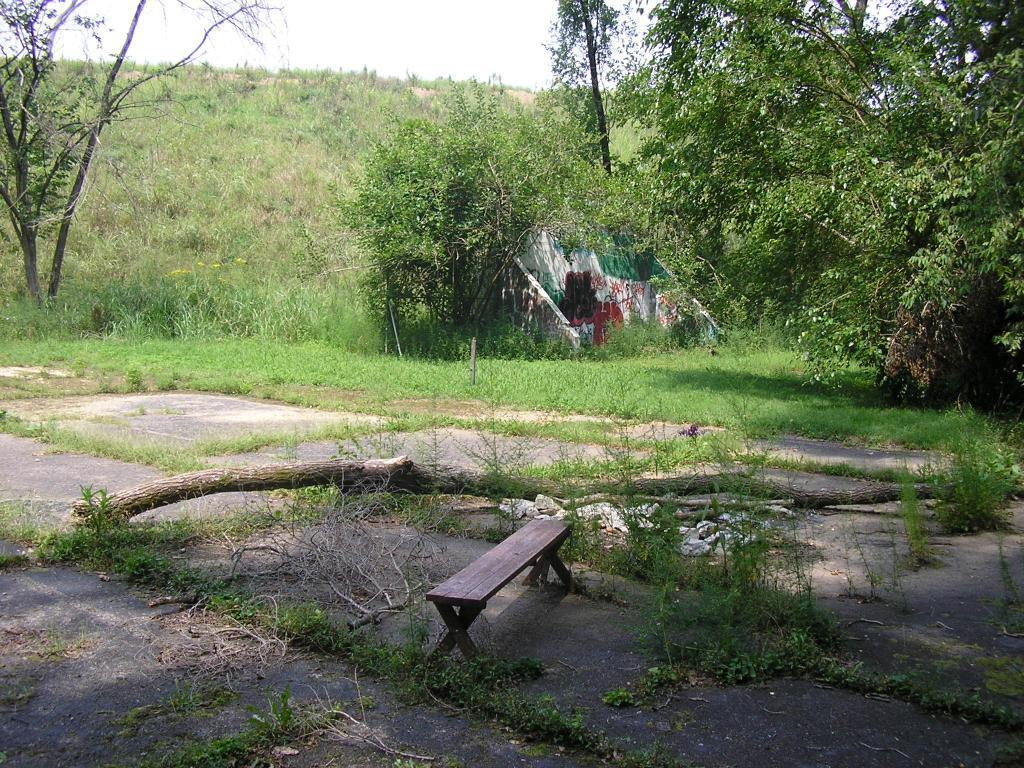What is located at the center of the image? There is a bench at the center of the image. What can be seen in the background of the image? There are trees in the background of the image. Can you see a clam holding a ring in the image? No, there is no clam or ring present in the image. 